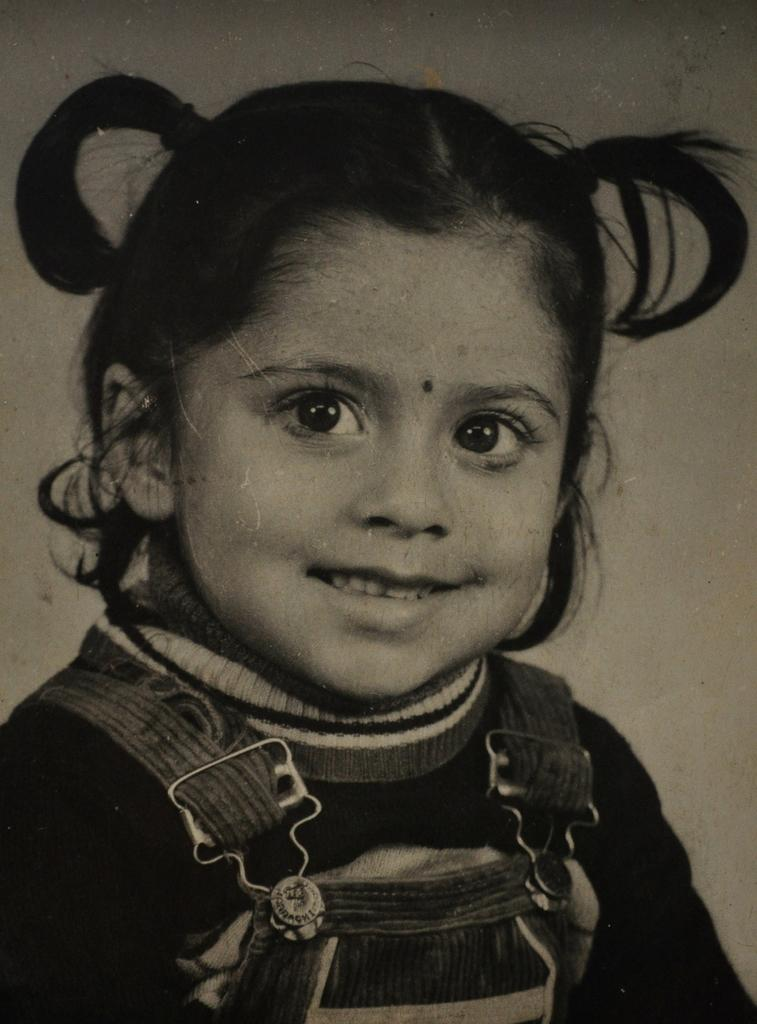What is the main subject of the picture? The main subject of the picture is a girl. What is the girl doing in the picture? The girl is smiling in the picture. What type of legal advice is the girl providing in the image? There is no indication in the image that the girl is providing legal advice, as she is simply smiling. How much wealth does the girl possess, as depicted in the image? There is no information about the girl's wealth in the image, as it only shows her smiling. 